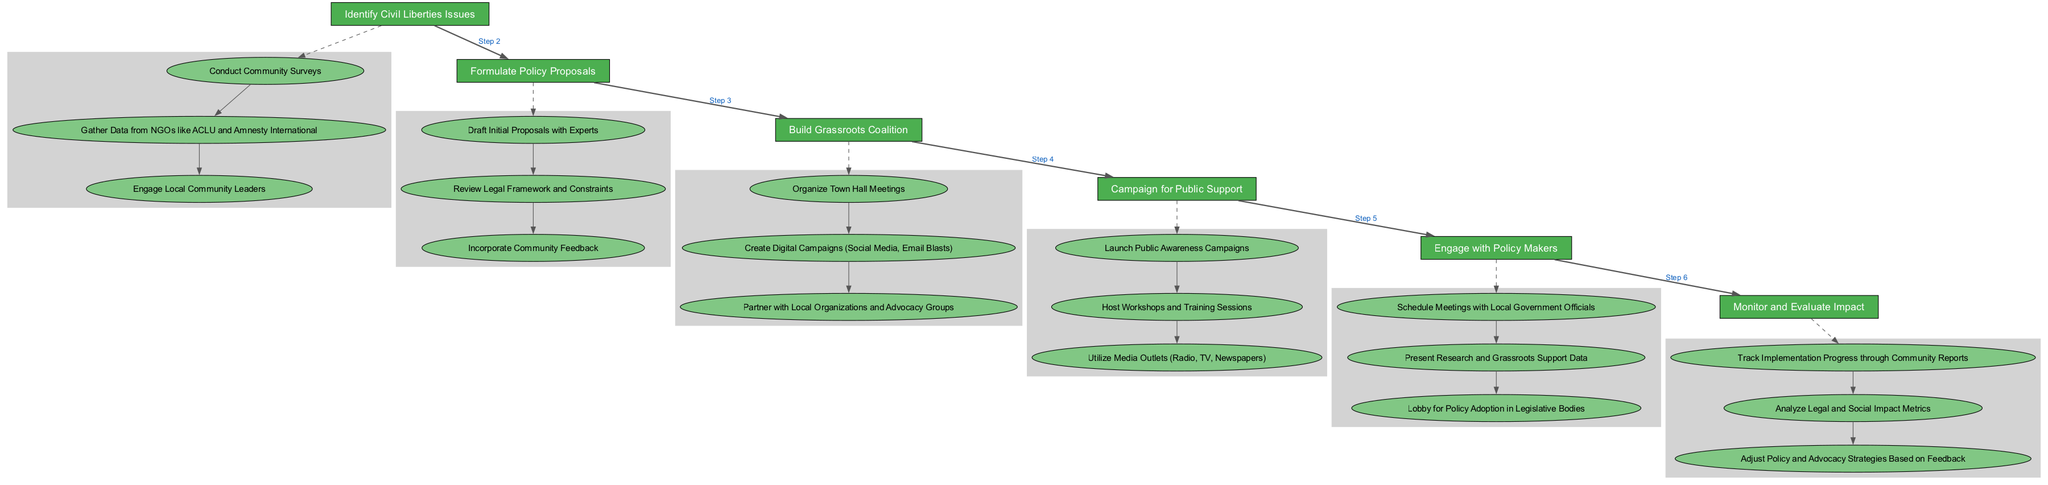What is the first step in the process? The first step listed in the diagram under "steps" is "Identify Civil Liberties Issues".
Answer: Identify Civil Liberties Issues How many activities are there in the "Build Grassroots Coalition" step? Upon examining the "Build Grassroots Coalition" step in the diagram, there are three activities outlined: "Organize Town Hall Meetings", "Create Digital Campaigns", and "Partner with Local Organizations and Advocacy Groups".
Answer: 3 Which step comes after "Formulate Policy Proposals"? The diagram shows a flow where the "Build Grassroots Coalition" step directly follows "Formulate Policy Proposals".
Answer: Build Grassroots Coalition What type of activities are included in the "Campaign for Public Support" step? The activities for "Campaign for Public Support" include "Launch Public Awareness Campaigns", "Host Workshops and Training Sessions", and "Utilize Media Outlets". These all aim to increase public awareness and engagement.
Answer: Launch Public Awareness Campaigns, Host Workshops and Training Sessions, Utilize Media Outlets What is the main purpose of the "Monitor and Evaluate Impact" step? This step is focused on assessing the progress and effects of implemented policies and advocacy strategies based on community feedback and impact metrics.
Answer: Assess progress and effects Which node has the highest number of edges connecting it in terms of activities? The "Formulate Policy Proposals" step has the most activities connected to it as it connects three activities: "Draft Initial Proposals with Experts", "Review Legal Framework and Constraints", and "Incorporate Community Feedback".
Answer: Formulate Policy Proposals What is the relationship between "Engage with Policy Makers" and "Campaign for Public Support"? In the diagram, "Engage with Policy Makers" follows "Campaign for Public Support", indicating that the latter is meant to build support before engaging with policymakers.
Answer: Engage with Policy Makers follows Campaign for Public Support How are activities visually represented in the diagram? Activities in the diagram are shown as ellipses with filled colors, indicating their belonging to specific steps, enhancing the structure and understanding of the process.
Answer: As ellipses 